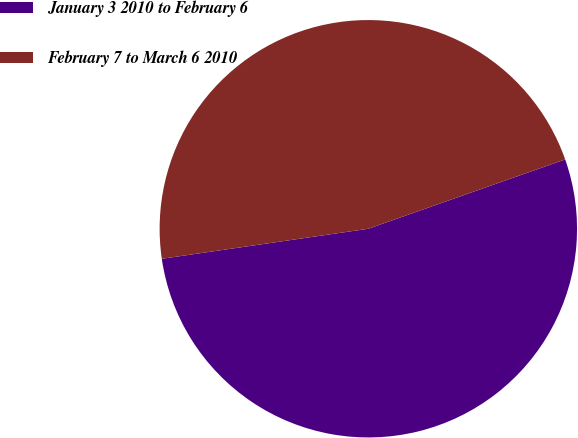Convert chart to OTSL. <chart><loc_0><loc_0><loc_500><loc_500><pie_chart><fcel>January 3 2010 to February 6<fcel>February 7 to March 6 2010<nl><fcel>53.09%<fcel>46.91%<nl></chart> 